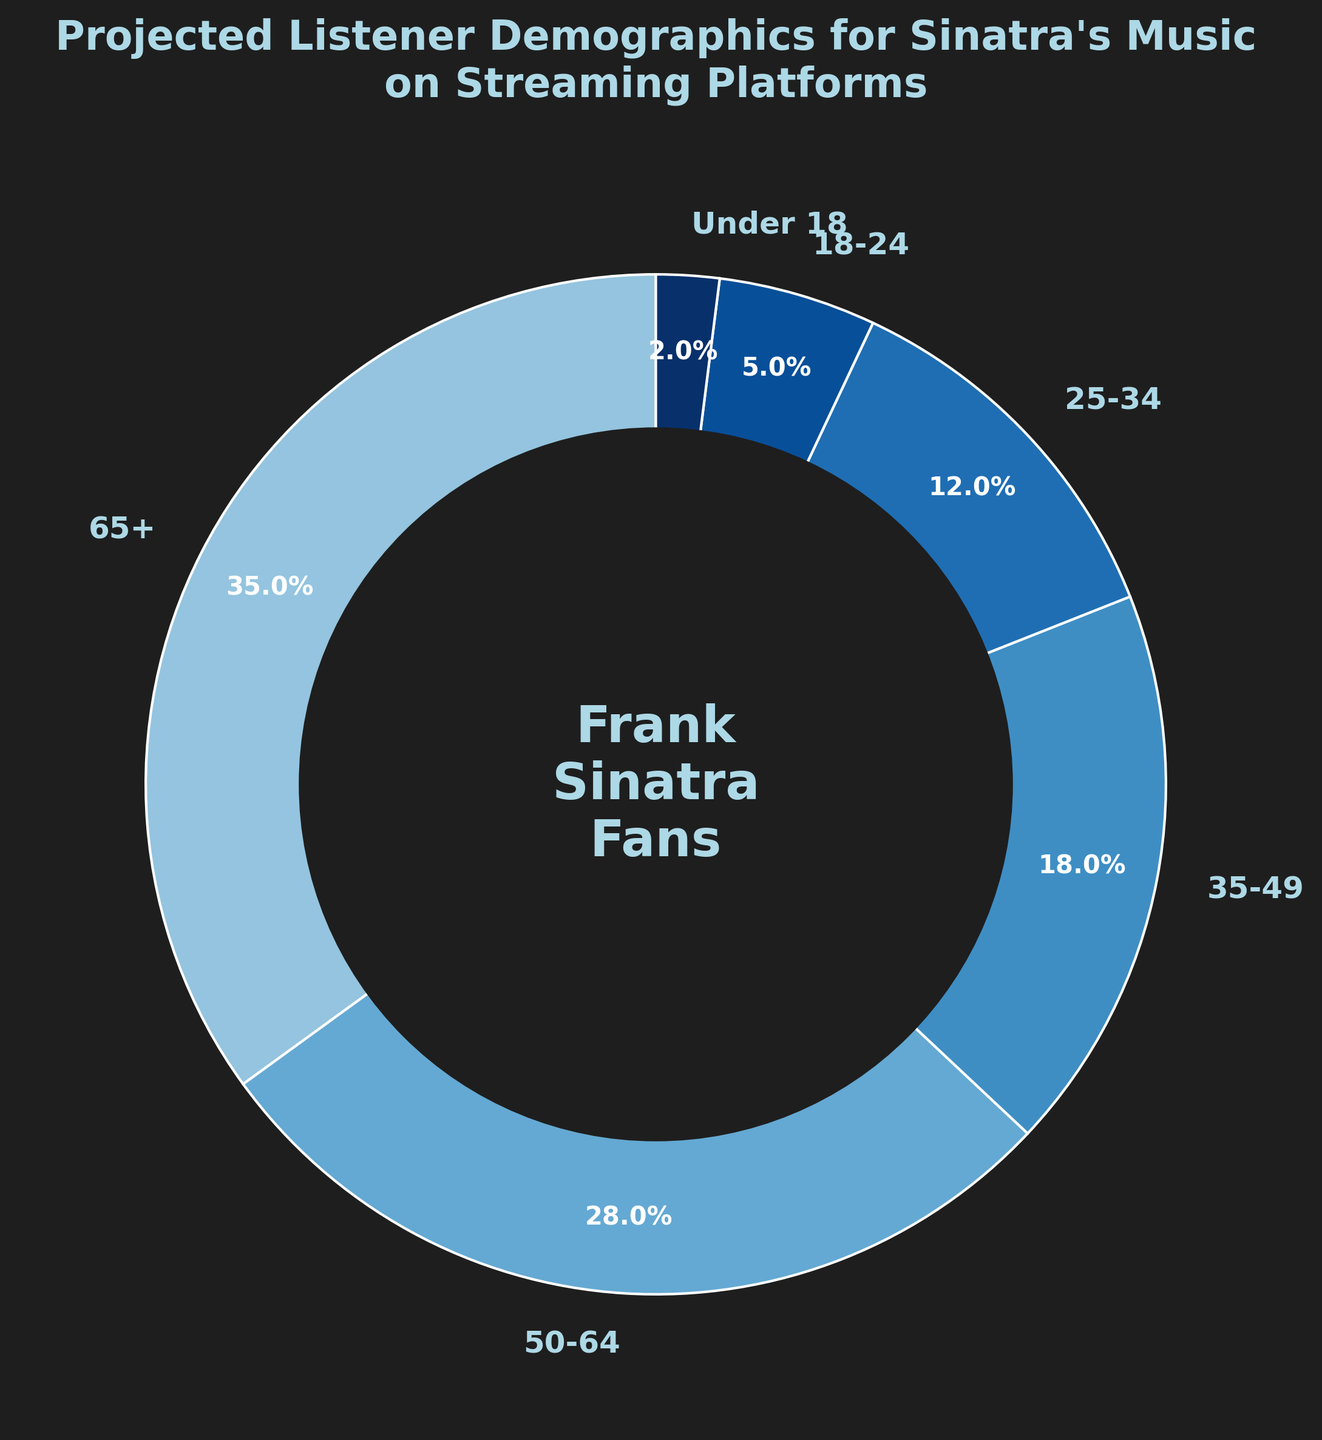What is the title of the chart? The title is located at the top of the figure in larger, bold text, making it easy to identify.
Answer: Projected Listener Demographics for Sinatra's Music on Streaming Platforms Which age group has the highest percentage of Frank Sinatra's listeners? By observing the chart's wedges and their labels, the largest wedge can be identified as the age group with the highest percentage.
Answer: 65+ What is the total percentage of listeners age 50 and older? Sum the percentages of the 50-64 and 65+ age groups: 28% + 35%.
Answer: 63% Which two age groups have the smallest percentage of listeners? By comparing the sizes and the percentages of the wedges in the chart, identify the two smallest segments.
Answer: 18-24 and Under 18 How much higher is the percentage of listeners aged 65+ compared to listeners aged 18-24? Subtract the percentage of the 18-24 age group from the percentage of the 65+ age group: 35% - 5%.
Answer: 30% What is the combined percentage of listeners aged 35-49 and 25-34? Sum the percentages of the 35-49 and 25-34 age groups: 18% + 12%.
Answer: 30% Which age group is represented by the darkest shade of blue? The chart uses different shades of blue, with the darkest shade typically indicating the smallest segment. Identify the segment with this color.
Answer: Under 18 Is there an age group where the percentage of listeners is exactly half of another age group's percentage? Compare the percentages visually to find if any age group's percentage is exactly half of another's.
Answer: Yes, 25-34 (12%) is half of 50-64 (24%) What is the difference in percentage between the age group 25-34 and 18-24? Subtract the percentage of the 18-24 age group from the percentage of the 25-34 age group: 12% - 5%.
Answer: 7% How does the percentage of listeners under 18 compare to the percentage of listeners aged 18-24? Compare the percentages visually to determine which one is smaller.
Answer: Under 18% is smaller (2% vs 5%) 